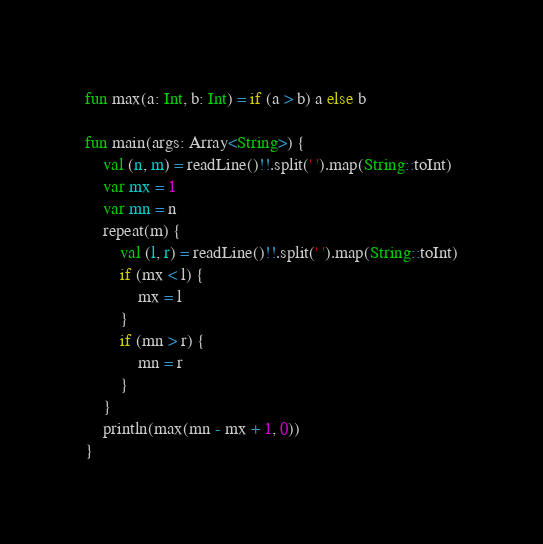<code> <loc_0><loc_0><loc_500><loc_500><_Kotlin_>fun max(a: Int, b: Int) = if (a > b) a else b

fun main(args: Array<String>) {
    val (n, m) = readLine()!!.split(' ').map(String::toInt)
    var mx = 1
    var mn = n
    repeat(m) {
        val (l, r) = readLine()!!.split(' ').map(String::toInt)
        if (mx < l) {
            mx = l
        }
        if (mn > r) {
            mn = r
        }
    }
    println(max(mn - mx + 1, 0))
}</code> 